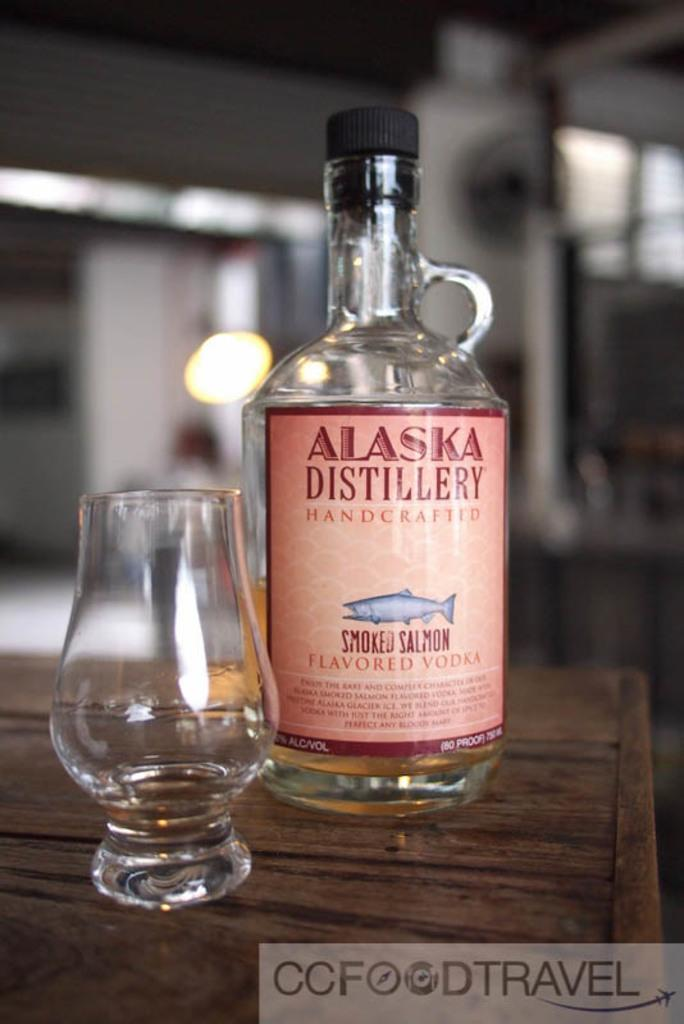<image>
Share a concise interpretation of the image provided. A bottle of Alaska Distillery Handcrafted Smoked Salmon Flavored Vodka sits on a table next to a glass. 